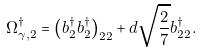Convert formula to latex. <formula><loc_0><loc_0><loc_500><loc_500>\Omega ^ { \dagger } _ { \gamma , 2 } = \left ( b ^ { \dagger } _ { 2 } b ^ { \dagger } _ { 2 } \right ) _ { 2 2 } + d \sqrt { \frac { 2 } { 7 } } b ^ { \dagger } _ { 2 2 } .</formula> 